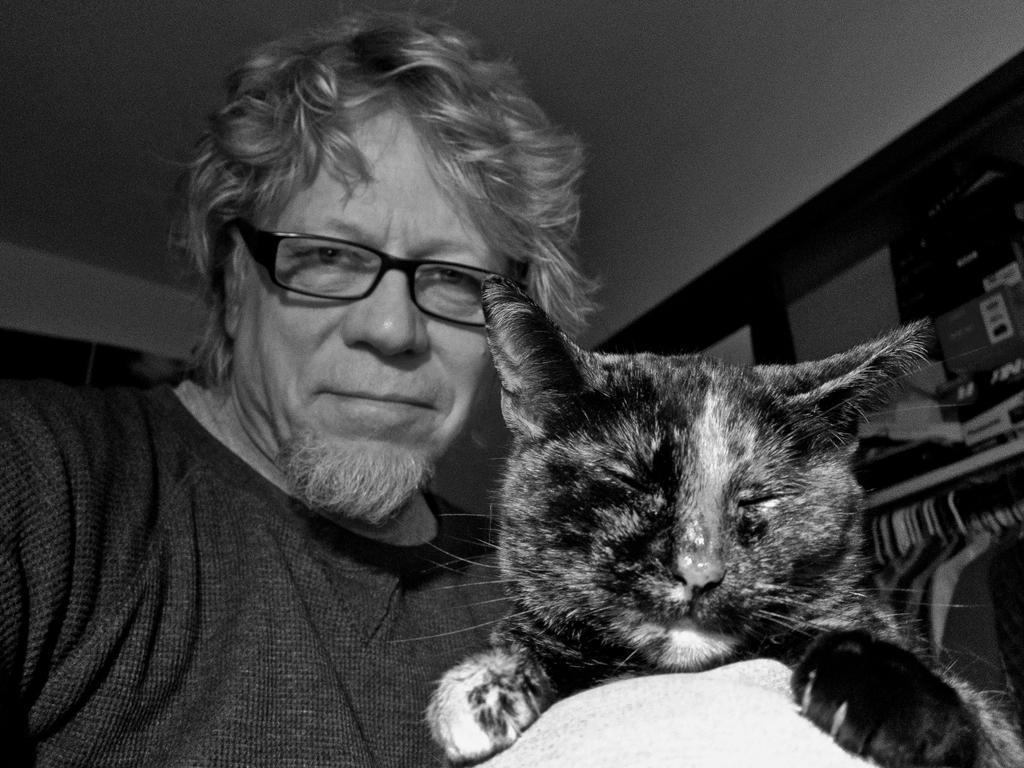How would you summarize this image in a sentence or two? This is a black and white picture, in this image we can see a cat and a person wearing the spectacles, also we can see some objects. 